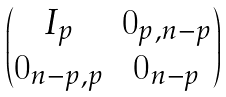Convert formula to latex. <formula><loc_0><loc_0><loc_500><loc_500>\begin{pmatrix} I _ { p } & 0 _ { p , n - p } \\ 0 _ { n - p , p } & 0 _ { n - p } \end{pmatrix}</formula> 